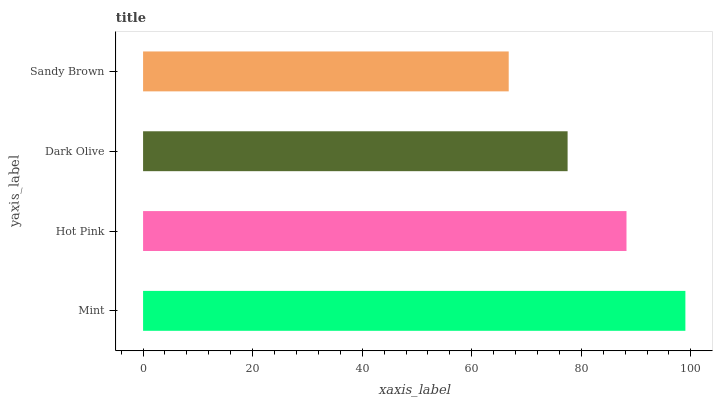Is Sandy Brown the minimum?
Answer yes or no. Yes. Is Mint the maximum?
Answer yes or no. Yes. Is Hot Pink the minimum?
Answer yes or no. No. Is Hot Pink the maximum?
Answer yes or no. No. Is Mint greater than Hot Pink?
Answer yes or no. Yes. Is Hot Pink less than Mint?
Answer yes or no. Yes. Is Hot Pink greater than Mint?
Answer yes or no. No. Is Mint less than Hot Pink?
Answer yes or no. No. Is Hot Pink the high median?
Answer yes or no. Yes. Is Dark Olive the low median?
Answer yes or no. Yes. Is Dark Olive the high median?
Answer yes or no. No. Is Sandy Brown the low median?
Answer yes or no. No. 